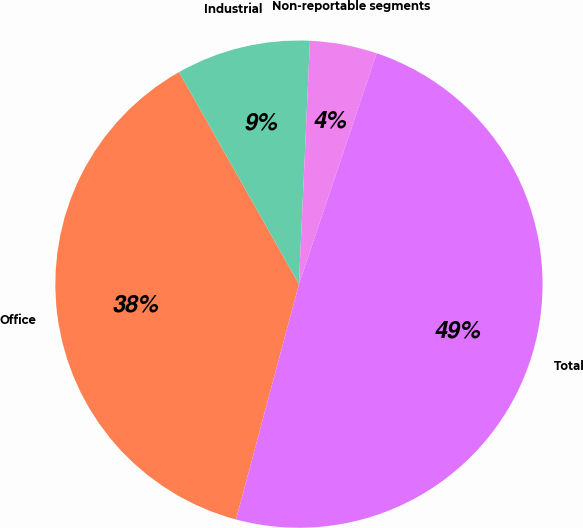<chart> <loc_0><loc_0><loc_500><loc_500><pie_chart><fcel>Office<fcel>Industrial<fcel>Non-reportable segments<fcel>Total<nl><fcel>37.65%<fcel>8.91%<fcel>4.45%<fcel>48.99%<nl></chart> 